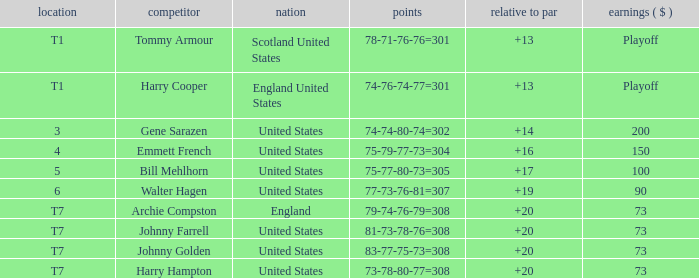What is the score for the United States when Harry Hampton is the player and the money is $73? 73-78-80-77=308. 